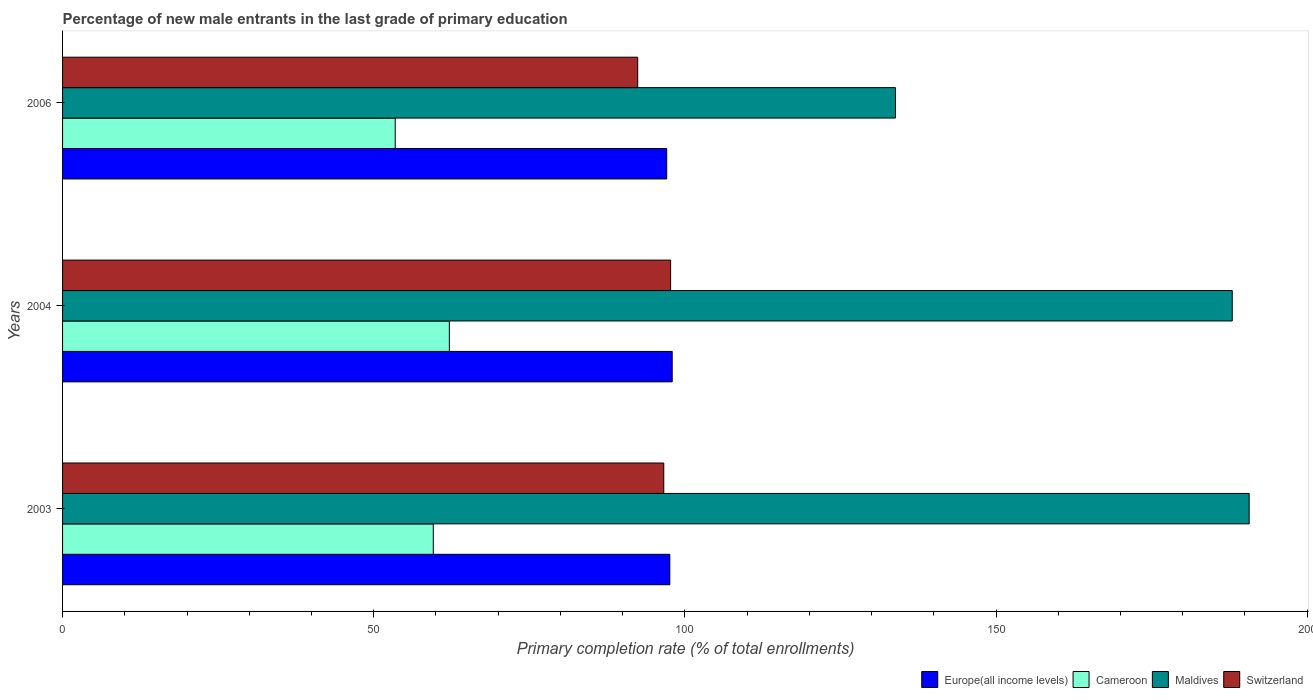How many groups of bars are there?
Your answer should be very brief. 3. Are the number of bars per tick equal to the number of legend labels?
Offer a very short reply. Yes. How many bars are there on the 3rd tick from the top?
Make the answer very short. 4. In how many cases, is the number of bars for a given year not equal to the number of legend labels?
Provide a short and direct response. 0. What is the percentage of new male entrants in Switzerland in 2006?
Make the answer very short. 92.42. Across all years, what is the maximum percentage of new male entrants in Europe(all income levels)?
Your answer should be very brief. 97.97. Across all years, what is the minimum percentage of new male entrants in Maldives?
Give a very brief answer. 133.84. In which year was the percentage of new male entrants in Cameroon maximum?
Your answer should be compact. 2004. What is the total percentage of new male entrants in Europe(all income levels) in the graph?
Offer a terse response. 292.63. What is the difference between the percentage of new male entrants in Cameroon in 2003 and that in 2006?
Ensure brevity in your answer.  6.11. What is the difference between the percentage of new male entrants in Maldives in 2004 and the percentage of new male entrants in Cameroon in 2006?
Your answer should be very brief. 134.5. What is the average percentage of new male entrants in Maldives per year?
Provide a short and direct response. 170.83. In the year 2003, what is the difference between the percentage of new male entrants in Switzerland and percentage of new male entrants in Cameroon?
Offer a terse response. 37.04. What is the ratio of the percentage of new male entrants in Switzerland in 2003 to that in 2006?
Ensure brevity in your answer.  1.05. Is the difference between the percentage of new male entrants in Switzerland in 2003 and 2004 greater than the difference between the percentage of new male entrants in Cameroon in 2003 and 2004?
Offer a terse response. Yes. What is the difference between the highest and the second highest percentage of new male entrants in Maldives?
Ensure brevity in your answer.  2.72. What is the difference between the highest and the lowest percentage of new male entrants in Switzerland?
Your response must be concise. 5.29. Is the sum of the percentage of new male entrants in Europe(all income levels) in 2003 and 2004 greater than the maximum percentage of new male entrants in Switzerland across all years?
Offer a terse response. Yes. Is it the case that in every year, the sum of the percentage of new male entrants in Cameroon and percentage of new male entrants in Switzerland is greater than the sum of percentage of new male entrants in Europe(all income levels) and percentage of new male entrants in Maldives?
Offer a very short reply. Yes. What does the 2nd bar from the top in 2006 represents?
Ensure brevity in your answer.  Maldives. What does the 4th bar from the bottom in 2003 represents?
Your answer should be compact. Switzerland. Is it the case that in every year, the sum of the percentage of new male entrants in Switzerland and percentage of new male entrants in Europe(all income levels) is greater than the percentage of new male entrants in Maldives?
Offer a very short reply. Yes. Are the values on the major ticks of X-axis written in scientific E-notation?
Your answer should be compact. No. Does the graph contain any zero values?
Make the answer very short. No. Where does the legend appear in the graph?
Provide a succinct answer. Bottom right. How many legend labels are there?
Offer a terse response. 4. What is the title of the graph?
Your answer should be very brief. Percentage of new male entrants in the last grade of primary education. Does "Djibouti" appear as one of the legend labels in the graph?
Keep it short and to the point. No. What is the label or title of the X-axis?
Ensure brevity in your answer.  Primary completion rate (% of total enrollments). What is the label or title of the Y-axis?
Give a very brief answer. Years. What is the Primary completion rate (% of total enrollments) of Europe(all income levels) in 2003?
Offer a very short reply. 97.58. What is the Primary completion rate (% of total enrollments) of Cameroon in 2003?
Provide a short and direct response. 59.57. What is the Primary completion rate (% of total enrollments) of Maldives in 2003?
Give a very brief answer. 190.68. What is the Primary completion rate (% of total enrollments) of Switzerland in 2003?
Keep it short and to the point. 96.61. What is the Primary completion rate (% of total enrollments) in Europe(all income levels) in 2004?
Your answer should be compact. 97.97. What is the Primary completion rate (% of total enrollments) in Cameroon in 2004?
Your response must be concise. 62.15. What is the Primary completion rate (% of total enrollments) in Maldives in 2004?
Your answer should be compact. 187.96. What is the Primary completion rate (% of total enrollments) of Switzerland in 2004?
Offer a terse response. 97.71. What is the Primary completion rate (% of total enrollments) of Europe(all income levels) in 2006?
Provide a short and direct response. 97.08. What is the Primary completion rate (% of total enrollments) in Cameroon in 2006?
Make the answer very short. 53.46. What is the Primary completion rate (% of total enrollments) of Maldives in 2006?
Provide a succinct answer. 133.84. What is the Primary completion rate (% of total enrollments) of Switzerland in 2006?
Offer a very short reply. 92.42. Across all years, what is the maximum Primary completion rate (% of total enrollments) in Europe(all income levels)?
Keep it short and to the point. 97.97. Across all years, what is the maximum Primary completion rate (% of total enrollments) of Cameroon?
Provide a succinct answer. 62.15. Across all years, what is the maximum Primary completion rate (% of total enrollments) in Maldives?
Your answer should be compact. 190.68. Across all years, what is the maximum Primary completion rate (% of total enrollments) in Switzerland?
Offer a terse response. 97.71. Across all years, what is the minimum Primary completion rate (% of total enrollments) in Europe(all income levels)?
Your answer should be very brief. 97.08. Across all years, what is the minimum Primary completion rate (% of total enrollments) in Cameroon?
Provide a succinct answer. 53.46. Across all years, what is the minimum Primary completion rate (% of total enrollments) in Maldives?
Your answer should be very brief. 133.84. Across all years, what is the minimum Primary completion rate (% of total enrollments) in Switzerland?
Offer a terse response. 92.42. What is the total Primary completion rate (% of total enrollments) of Europe(all income levels) in the graph?
Offer a very short reply. 292.63. What is the total Primary completion rate (% of total enrollments) of Cameroon in the graph?
Your response must be concise. 175.18. What is the total Primary completion rate (% of total enrollments) of Maldives in the graph?
Your answer should be compact. 512.48. What is the total Primary completion rate (% of total enrollments) in Switzerland in the graph?
Offer a terse response. 286.74. What is the difference between the Primary completion rate (% of total enrollments) of Europe(all income levels) in 2003 and that in 2004?
Your answer should be very brief. -0.38. What is the difference between the Primary completion rate (% of total enrollments) of Cameroon in 2003 and that in 2004?
Give a very brief answer. -2.58. What is the difference between the Primary completion rate (% of total enrollments) in Maldives in 2003 and that in 2004?
Ensure brevity in your answer.  2.72. What is the difference between the Primary completion rate (% of total enrollments) of Switzerland in 2003 and that in 2004?
Your answer should be compact. -1.1. What is the difference between the Primary completion rate (% of total enrollments) of Europe(all income levels) in 2003 and that in 2006?
Your response must be concise. 0.5. What is the difference between the Primary completion rate (% of total enrollments) in Cameroon in 2003 and that in 2006?
Offer a terse response. 6.11. What is the difference between the Primary completion rate (% of total enrollments) in Maldives in 2003 and that in 2006?
Make the answer very short. 56.84. What is the difference between the Primary completion rate (% of total enrollments) of Switzerland in 2003 and that in 2006?
Offer a very short reply. 4.19. What is the difference between the Primary completion rate (% of total enrollments) of Europe(all income levels) in 2004 and that in 2006?
Give a very brief answer. 0.88. What is the difference between the Primary completion rate (% of total enrollments) in Cameroon in 2004 and that in 2006?
Make the answer very short. 8.69. What is the difference between the Primary completion rate (% of total enrollments) in Maldives in 2004 and that in 2006?
Your answer should be very brief. 54.12. What is the difference between the Primary completion rate (% of total enrollments) in Switzerland in 2004 and that in 2006?
Your answer should be very brief. 5.29. What is the difference between the Primary completion rate (% of total enrollments) of Europe(all income levels) in 2003 and the Primary completion rate (% of total enrollments) of Cameroon in 2004?
Keep it short and to the point. 35.43. What is the difference between the Primary completion rate (% of total enrollments) in Europe(all income levels) in 2003 and the Primary completion rate (% of total enrollments) in Maldives in 2004?
Your answer should be compact. -90.38. What is the difference between the Primary completion rate (% of total enrollments) of Europe(all income levels) in 2003 and the Primary completion rate (% of total enrollments) of Switzerland in 2004?
Your answer should be compact. -0.13. What is the difference between the Primary completion rate (% of total enrollments) of Cameroon in 2003 and the Primary completion rate (% of total enrollments) of Maldives in 2004?
Your response must be concise. -128.39. What is the difference between the Primary completion rate (% of total enrollments) of Cameroon in 2003 and the Primary completion rate (% of total enrollments) of Switzerland in 2004?
Offer a very short reply. -38.14. What is the difference between the Primary completion rate (% of total enrollments) of Maldives in 2003 and the Primary completion rate (% of total enrollments) of Switzerland in 2004?
Your answer should be compact. 92.97. What is the difference between the Primary completion rate (% of total enrollments) in Europe(all income levels) in 2003 and the Primary completion rate (% of total enrollments) in Cameroon in 2006?
Ensure brevity in your answer.  44.13. What is the difference between the Primary completion rate (% of total enrollments) in Europe(all income levels) in 2003 and the Primary completion rate (% of total enrollments) in Maldives in 2006?
Offer a terse response. -36.25. What is the difference between the Primary completion rate (% of total enrollments) of Europe(all income levels) in 2003 and the Primary completion rate (% of total enrollments) of Switzerland in 2006?
Provide a short and direct response. 5.16. What is the difference between the Primary completion rate (% of total enrollments) of Cameroon in 2003 and the Primary completion rate (% of total enrollments) of Maldives in 2006?
Keep it short and to the point. -74.27. What is the difference between the Primary completion rate (% of total enrollments) in Cameroon in 2003 and the Primary completion rate (% of total enrollments) in Switzerland in 2006?
Your answer should be very brief. -32.85. What is the difference between the Primary completion rate (% of total enrollments) in Maldives in 2003 and the Primary completion rate (% of total enrollments) in Switzerland in 2006?
Ensure brevity in your answer.  98.26. What is the difference between the Primary completion rate (% of total enrollments) in Europe(all income levels) in 2004 and the Primary completion rate (% of total enrollments) in Cameroon in 2006?
Make the answer very short. 44.51. What is the difference between the Primary completion rate (% of total enrollments) of Europe(all income levels) in 2004 and the Primary completion rate (% of total enrollments) of Maldives in 2006?
Provide a succinct answer. -35.87. What is the difference between the Primary completion rate (% of total enrollments) of Europe(all income levels) in 2004 and the Primary completion rate (% of total enrollments) of Switzerland in 2006?
Make the answer very short. 5.55. What is the difference between the Primary completion rate (% of total enrollments) in Cameroon in 2004 and the Primary completion rate (% of total enrollments) in Maldives in 2006?
Provide a succinct answer. -71.69. What is the difference between the Primary completion rate (% of total enrollments) of Cameroon in 2004 and the Primary completion rate (% of total enrollments) of Switzerland in 2006?
Keep it short and to the point. -30.27. What is the difference between the Primary completion rate (% of total enrollments) in Maldives in 2004 and the Primary completion rate (% of total enrollments) in Switzerland in 2006?
Your response must be concise. 95.54. What is the average Primary completion rate (% of total enrollments) of Europe(all income levels) per year?
Keep it short and to the point. 97.54. What is the average Primary completion rate (% of total enrollments) of Cameroon per year?
Ensure brevity in your answer.  58.39. What is the average Primary completion rate (% of total enrollments) in Maldives per year?
Your answer should be compact. 170.83. What is the average Primary completion rate (% of total enrollments) in Switzerland per year?
Provide a short and direct response. 95.58. In the year 2003, what is the difference between the Primary completion rate (% of total enrollments) in Europe(all income levels) and Primary completion rate (% of total enrollments) in Cameroon?
Your response must be concise. 38.01. In the year 2003, what is the difference between the Primary completion rate (% of total enrollments) in Europe(all income levels) and Primary completion rate (% of total enrollments) in Maldives?
Keep it short and to the point. -93.1. In the year 2003, what is the difference between the Primary completion rate (% of total enrollments) in Europe(all income levels) and Primary completion rate (% of total enrollments) in Switzerland?
Provide a succinct answer. 0.97. In the year 2003, what is the difference between the Primary completion rate (% of total enrollments) in Cameroon and Primary completion rate (% of total enrollments) in Maldives?
Give a very brief answer. -131.11. In the year 2003, what is the difference between the Primary completion rate (% of total enrollments) of Cameroon and Primary completion rate (% of total enrollments) of Switzerland?
Make the answer very short. -37.04. In the year 2003, what is the difference between the Primary completion rate (% of total enrollments) of Maldives and Primary completion rate (% of total enrollments) of Switzerland?
Your response must be concise. 94.07. In the year 2004, what is the difference between the Primary completion rate (% of total enrollments) in Europe(all income levels) and Primary completion rate (% of total enrollments) in Cameroon?
Offer a terse response. 35.81. In the year 2004, what is the difference between the Primary completion rate (% of total enrollments) in Europe(all income levels) and Primary completion rate (% of total enrollments) in Maldives?
Provide a short and direct response. -90. In the year 2004, what is the difference between the Primary completion rate (% of total enrollments) of Europe(all income levels) and Primary completion rate (% of total enrollments) of Switzerland?
Your response must be concise. 0.26. In the year 2004, what is the difference between the Primary completion rate (% of total enrollments) of Cameroon and Primary completion rate (% of total enrollments) of Maldives?
Make the answer very short. -125.81. In the year 2004, what is the difference between the Primary completion rate (% of total enrollments) in Cameroon and Primary completion rate (% of total enrollments) in Switzerland?
Make the answer very short. -35.56. In the year 2004, what is the difference between the Primary completion rate (% of total enrollments) of Maldives and Primary completion rate (% of total enrollments) of Switzerland?
Give a very brief answer. 90.25. In the year 2006, what is the difference between the Primary completion rate (% of total enrollments) of Europe(all income levels) and Primary completion rate (% of total enrollments) of Cameroon?
Your answer should be compact. 43.62. In the year 2006, what is the difference between the Primary completion rate (% of total enrollments) in Europe(all income levels) and Primary completion rate (% of total enrollments) in Maldives?
Your response must be concise. -36.76. In the year 2006, what is the difference between the Primary completion rate (% of total enrollments) of Europe(all income levels) and Primary completion rate (% of total enrollments) of Switzerland?
Keep it short and to the point. 4.66. In the year 2006, what is the difference between the Primary completion rate (% of total enrollments) of Cameroon and Primary completion rate (% of total enrollments) of Maldives?
Make the answer very short. -80.38. In the year 2006, what is the difference between the Primary completion rate (% of total enrollments) of Cameroon and Primary completion rate (% of total enrollments) of Switzerland?
Your response must be concise. -38.96. In the year 2006, what is the difference between the Primary completion rate (% of total enrollments) in Maldives and Primary completion rate (% of total enrollments) in Switzerland?
Give a very brief answer. 41.42. What is the ratio of the Primary completion rate (% of total enrollments) in Europe(all income levels) in 2003 to that in 2004?
Your answer should be compact. 1. What is the ratio of the Primary completion rate (% of total enrollments) of Cameroon in 2003 to that in 2004?
Ensure brevity in your answer.  0.96. What is the ratio of the Primary completion rate (% of total enrollments) in Maldives in 2003 to that in 2004?
Your response must be concise. 1.01. What is the ratio of the Primary completion rate (% of total enrollments) in Switzerland in 2003 to that in 2004?
Provide a short and direct response. 0.99. What is the ratio of the Primary completion rate (% of total enrollments) of Europe(all income levels) in 2003 to that in 2006?
Give a very brief answer. 1.01. What is the ratio of the Primary completion rate (% of total enrollments) in Cameroon in 2003 to that in 2006?
Ensure brevity in your answer.  1.11. What is the ratio of the Primary completion rate (% of total enrollments) of Maldives in 2003 to that in 2006?
Provide a succinct answer. 1.42. What is the ratio of the Primary completion rate (% of total enrollments) in Switzerland in 2003 to that in 2006?
Provide a short and direct response. 1.05. What is the ratio of the Primary completion rate (% of total enrollments) in Europe(all income levels) in 2004 to that in 2006?
Your response must be concise. 1.01. What is the ratio of the Primary completion rate (% of total enrollments) in Cameroon in 2004 to that in 2006?
Your response must be concise. 1.16. What is the ratio of the Primary completion rate (% of total enrollments) of Maldives in 2004 to that in 2006?
Provide a short and direct response. 1.4. What is the ratio of the Primary completion rate (% of total enrollments) of Switzerland in 2004 to that in 2006?
Keep it short and to the point. 1.06. What is the difference between the highest and the second highest Primary completion rate (% of total enrollments) of Europe(all income levels)?
Offer a terse response. 0.38. What is the difference between the highest and the second highest Primary completion rate (% of total enrollments) of Cameroon?
Your answer should be compact. 2.58. What is the difference between the highest and the second highest Primary completion rate (% of total enrollments) in Maldives?
Offer a terse response. 2.72. What is the difference between the highest and the second highest Primary completion rate (% of total enrollments) in Switzerland?
Keep it short and to the point. 1.1. What is the difference between the highest and the lowest Primary completion rate (% of total enrollments) in Europe(all income levels)?
Your answer should be compact. 0.88. What is the difference between the highest and the lowest Primary completion rate (% of total enrollments) in Cameroon?
Keep it short and to the point. 8.69. What is the difference between the highest and the lowest Primary completion rate (% of total enrollments) in Maldives?
Your response must be concise. 56.84. What is the difference between the highest and the lowest Primary completion rate (% of total enrollments) in Switzerland?
Your response must be concise. 5.29. 